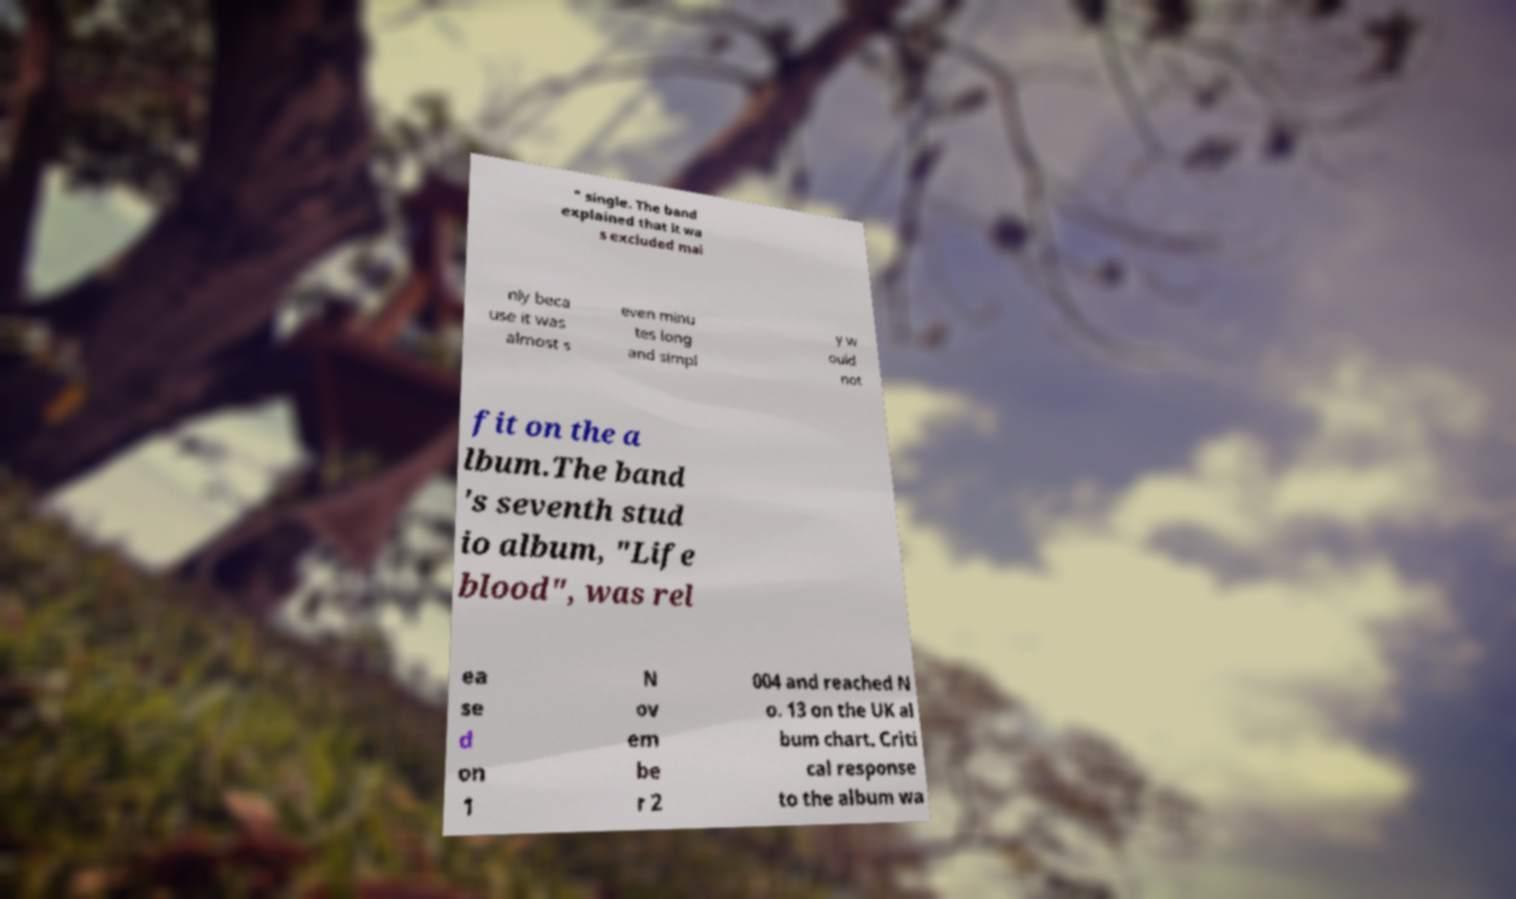What messages or text are displayed in this image? I need them in a readable, typed format. " single. The band explained that it wa s excluded mai nly beca use it was almost s even minu tes long and simpl y w ould not fit on the a lbum.The band 's seventh stud io album, "Life blood", was rel ea se d on 1 N ov em be r 2 004 and reached N o. 13 on the UK al bum chart. Criti cal response to the album wa 